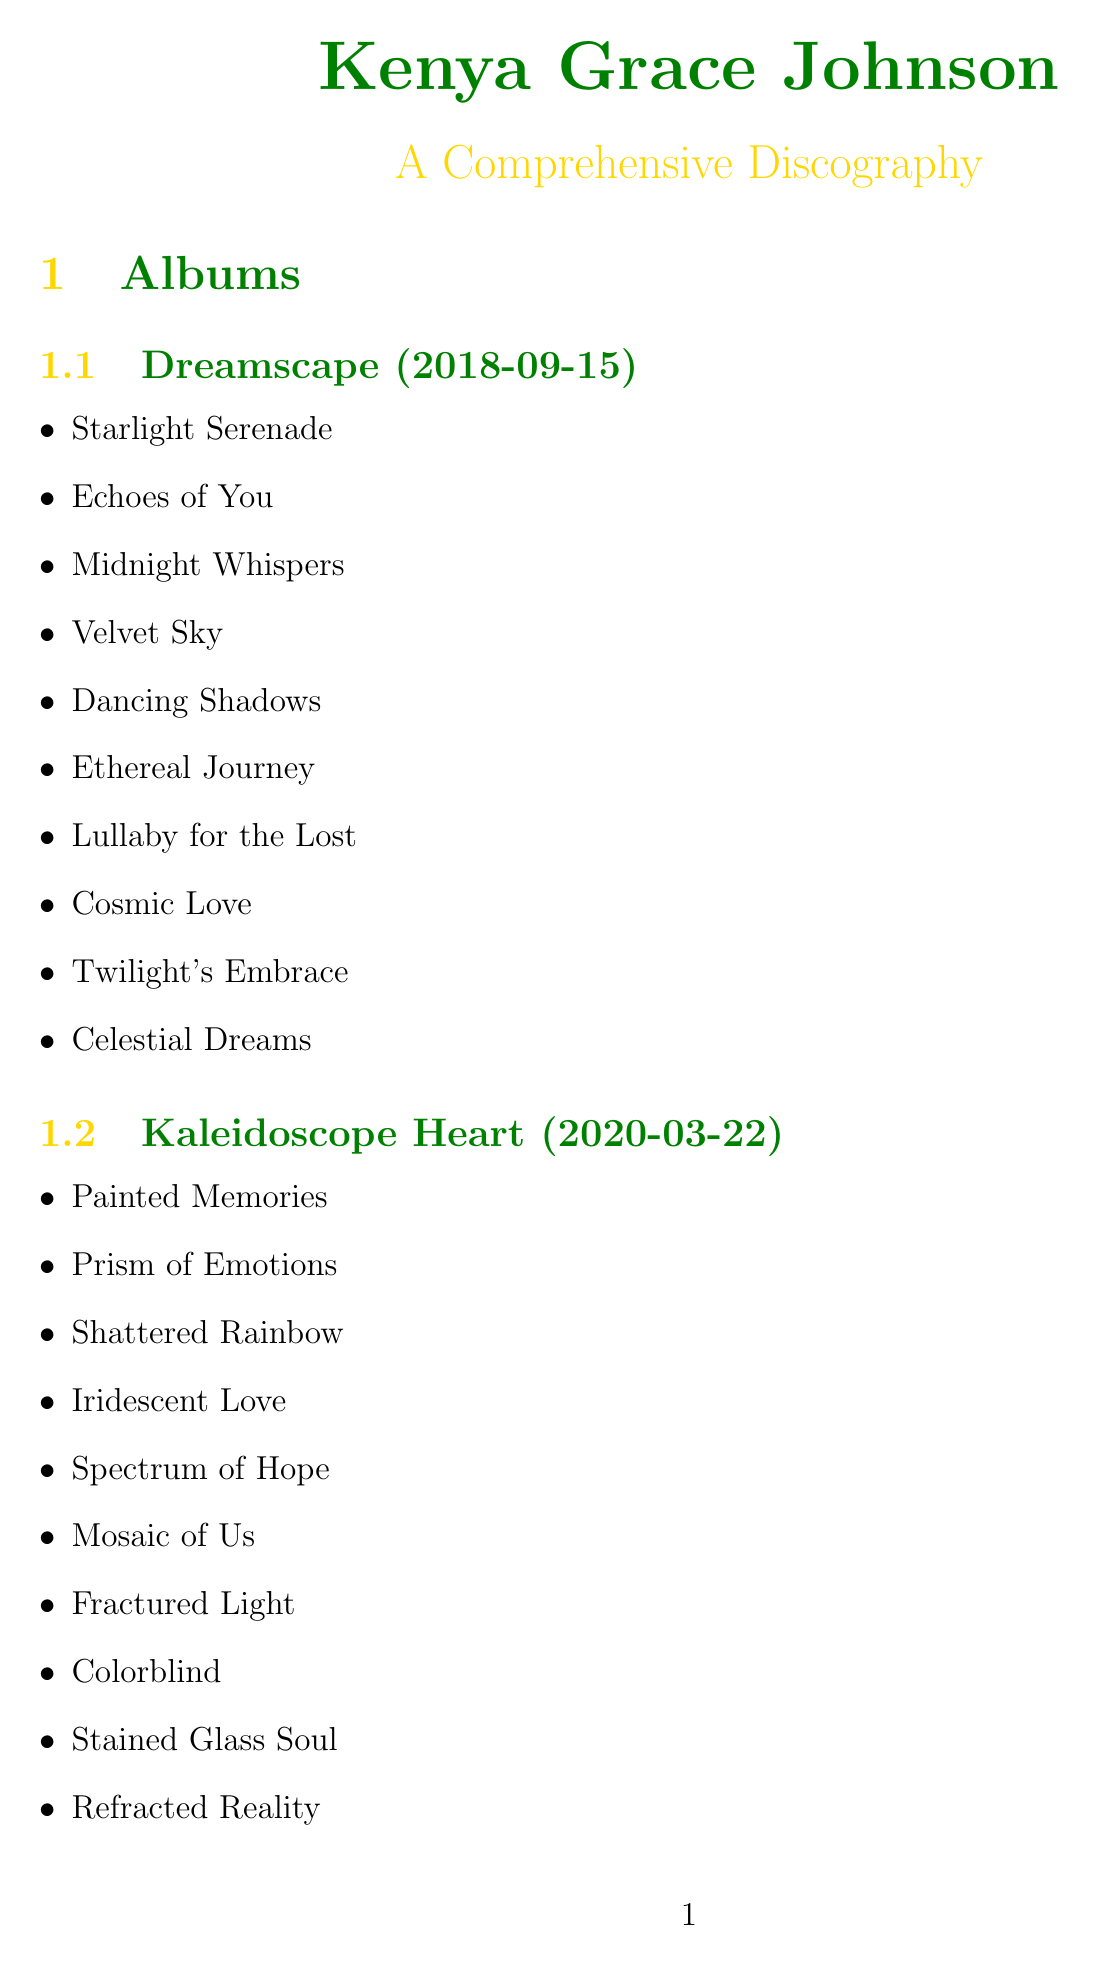What is the title of Kenya Grace Johnson's first album? The title of the first album listed is "Dreamscape."
Answer: Dreamscape When was the album "Kaleidoscope Heart" released? The release date for "Kaleidoscope Heart" is mentioned in the document as 2020-03-22.
Answer: 2020-03-22 How many tracks are there in the album "Euphoria"? The document lists 10 tracks under "Euphoria."
Answer: 10 Who collaborated with Kenya Grace Johnson on the song "Heartbeat"? The document states that Ella Mai collaborated with Kenya Grace Johnson on "Heartbeat."
Answer: Ella Mai Which award did Kenya Grace Johnson win in 2019? The document indicates she won "Best New Artist" at the BET Awards in 2019.
Answer: Best New Artist What is the name of Kenya Grace Johnson's fan club? The document mentions that the fan club is called "Grace Notes."
Answer: Grace Notes What was the release date of the single "Strangers"? The release date for the single "Strangers" is provided as 2023-05-12.
Answer: 2023-05-12 How many exclusive content types does the fan club offer? The document lists four exclusive content types provided by the fan club.
Answer: Four 